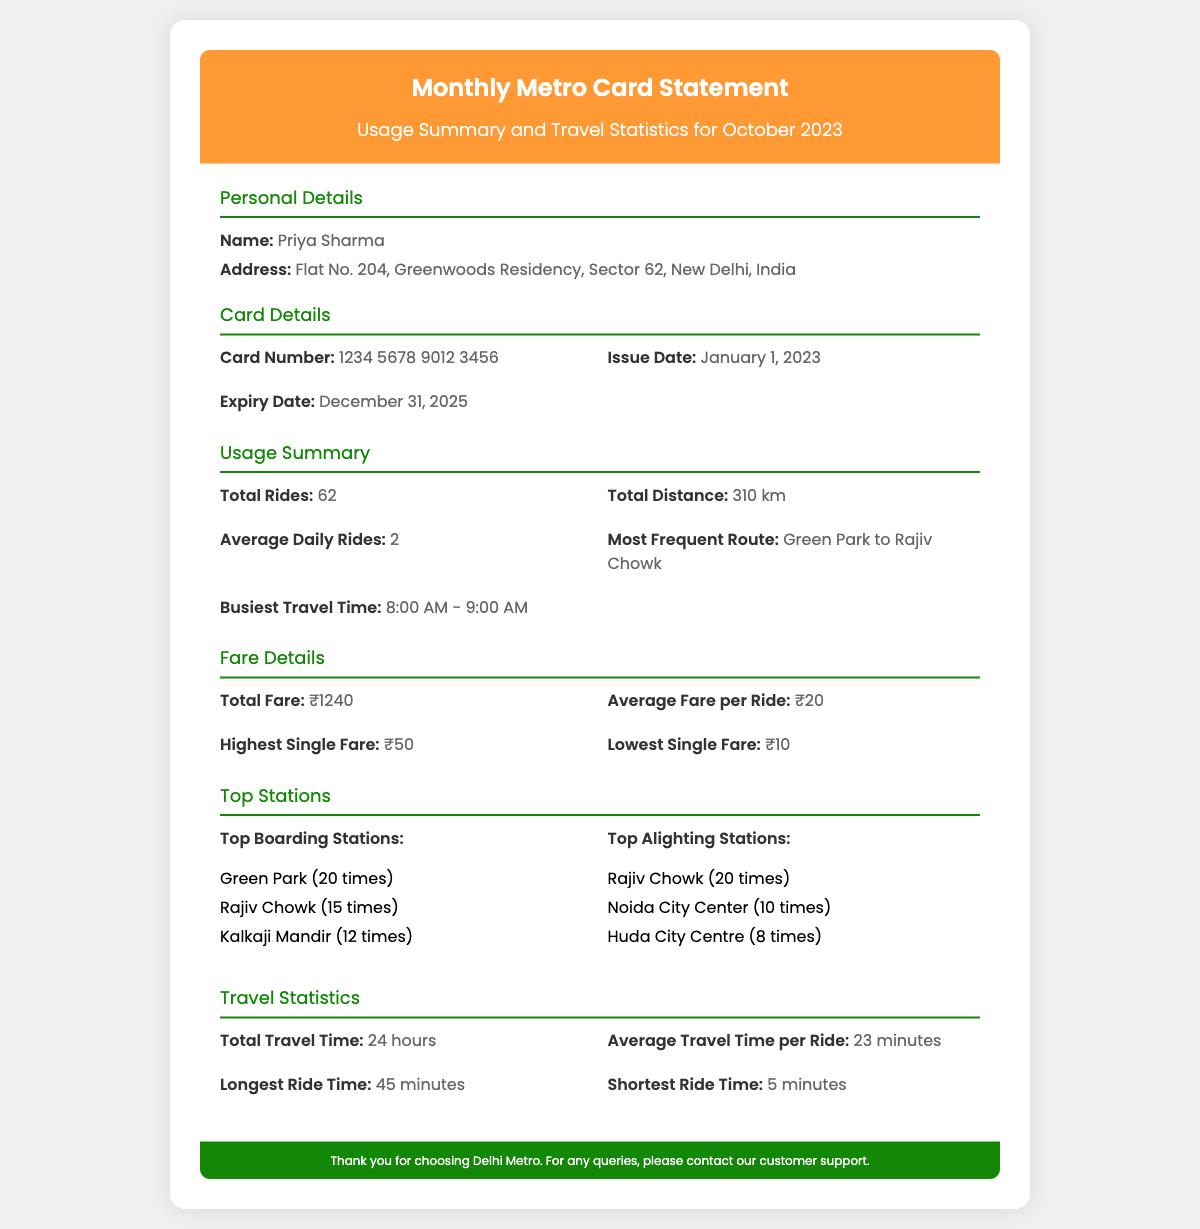What is the total number of rides taken? The total number of rides taken is specified in the Usage Summary section of the document.
Answer: 62 What is the average fare per ride? The average fare per ride is stated in the Fare Details section of the document.
Answer: ₹20 Who is the cardholder? The cardholder's name is mentioned in the Personal Details section.
Answer: Priya Sharma What is the busiest travel time? The busiest travel time is provided in the Usage Summary section.
Answer: 8:00 AM - 9:00 AM What is the highest single fare? The highest single fare is listed in the Fare Details section of the statement.
Answer: ₹50 Which route is most frequently traveled? The most frequent route can be found in the Usage Summary section.
Answer: Green Park to Rajiv Chowk What is the expiry date of the metro card? The expiry date is mentioned in the Card Details section of the document.
Answer: December 31, 2025 What is the total distance traveled? The total distance traveled is noted in the Usage Summary section.
Answer: 310 km What are the top boarding stations? The top boarding stations are listed in the Top Stations section of the document.
Answer: Green Park, Rajiv Chowk, Kalkaji Mandir 